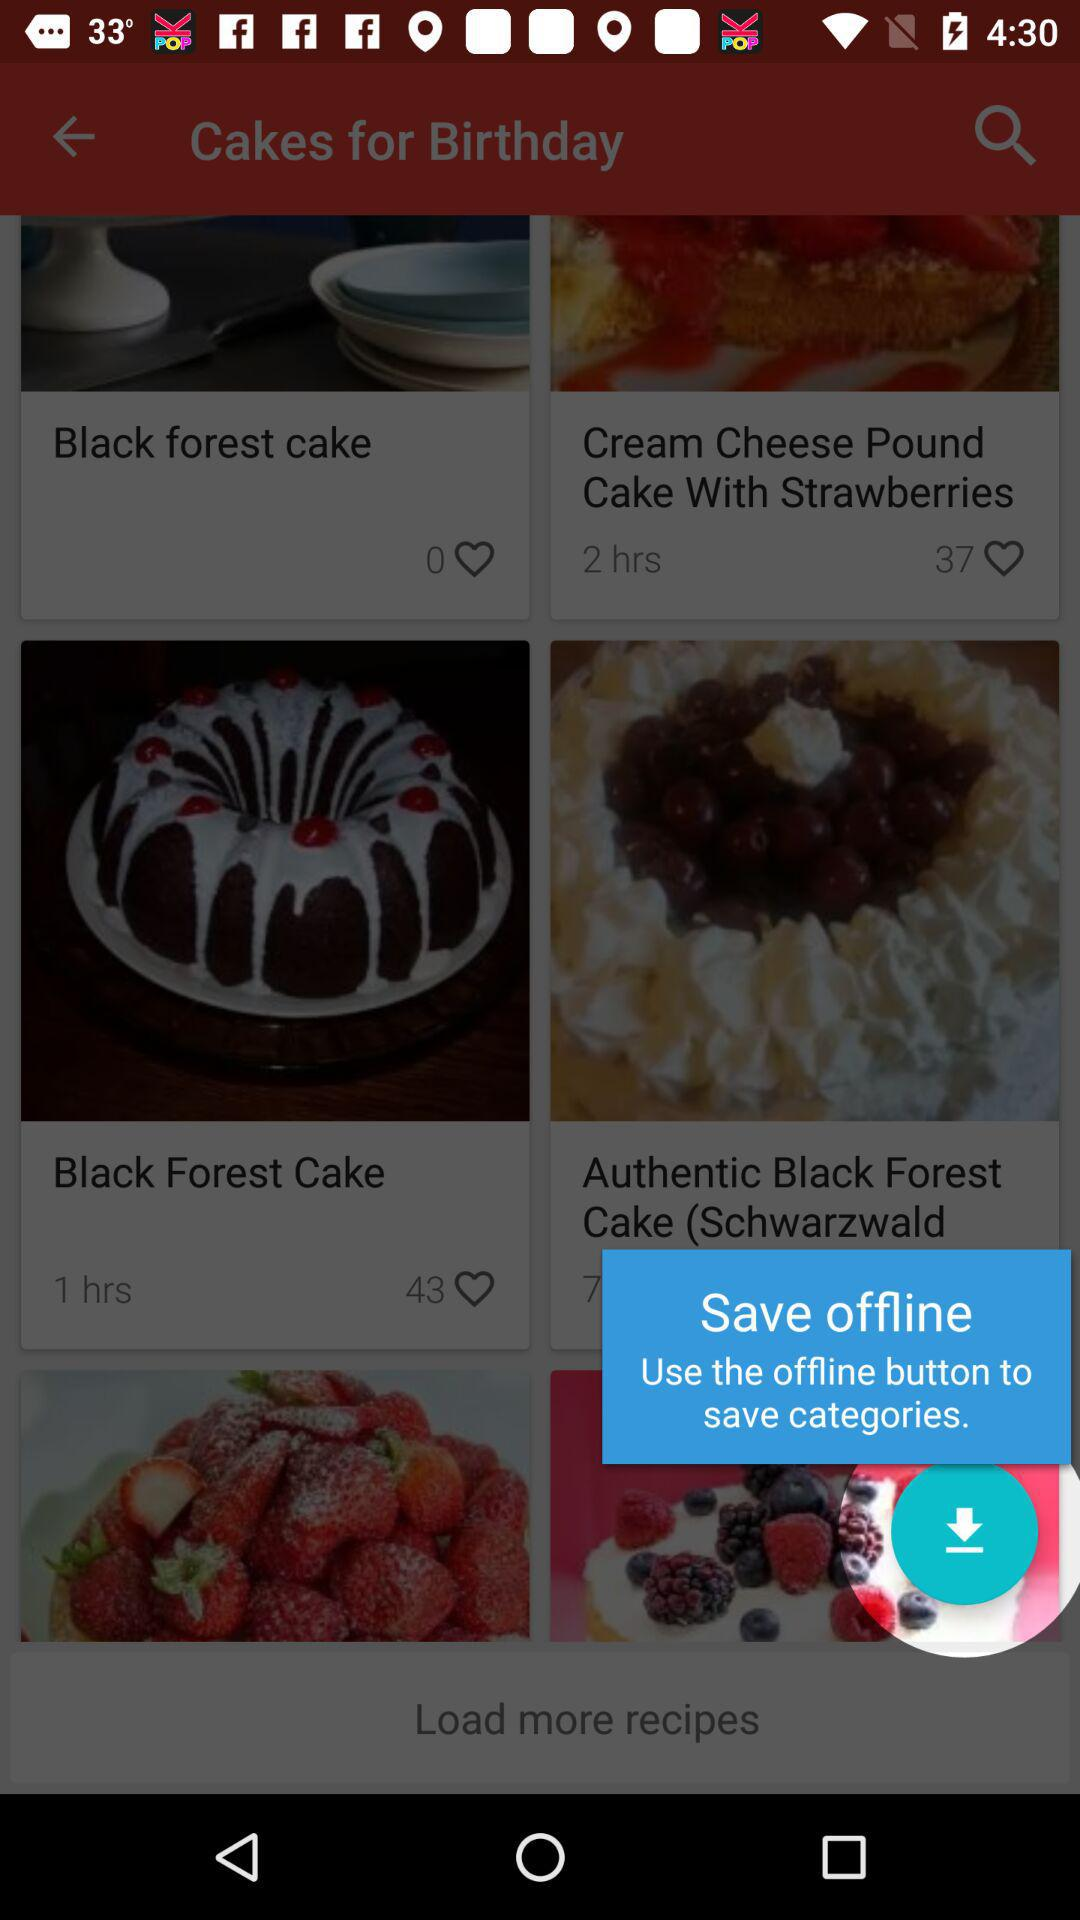When was the "Cream Cheese Pound Cake With Strawberries" recipe posted? The recipe was posted 2 hours ago. 